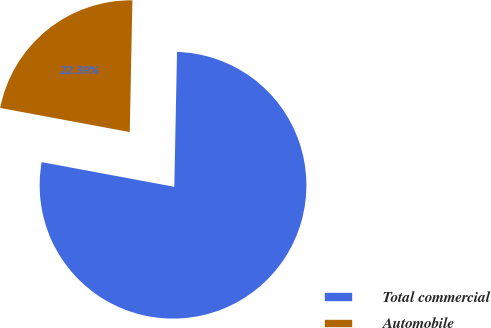<chart> <loc_0><loc_0><loc_500><loc_500><pie_chart><fcel>Total commercial<fcel>Automobile<nl><fcel>77.61%<fcel>22.39%<nl></chart> 